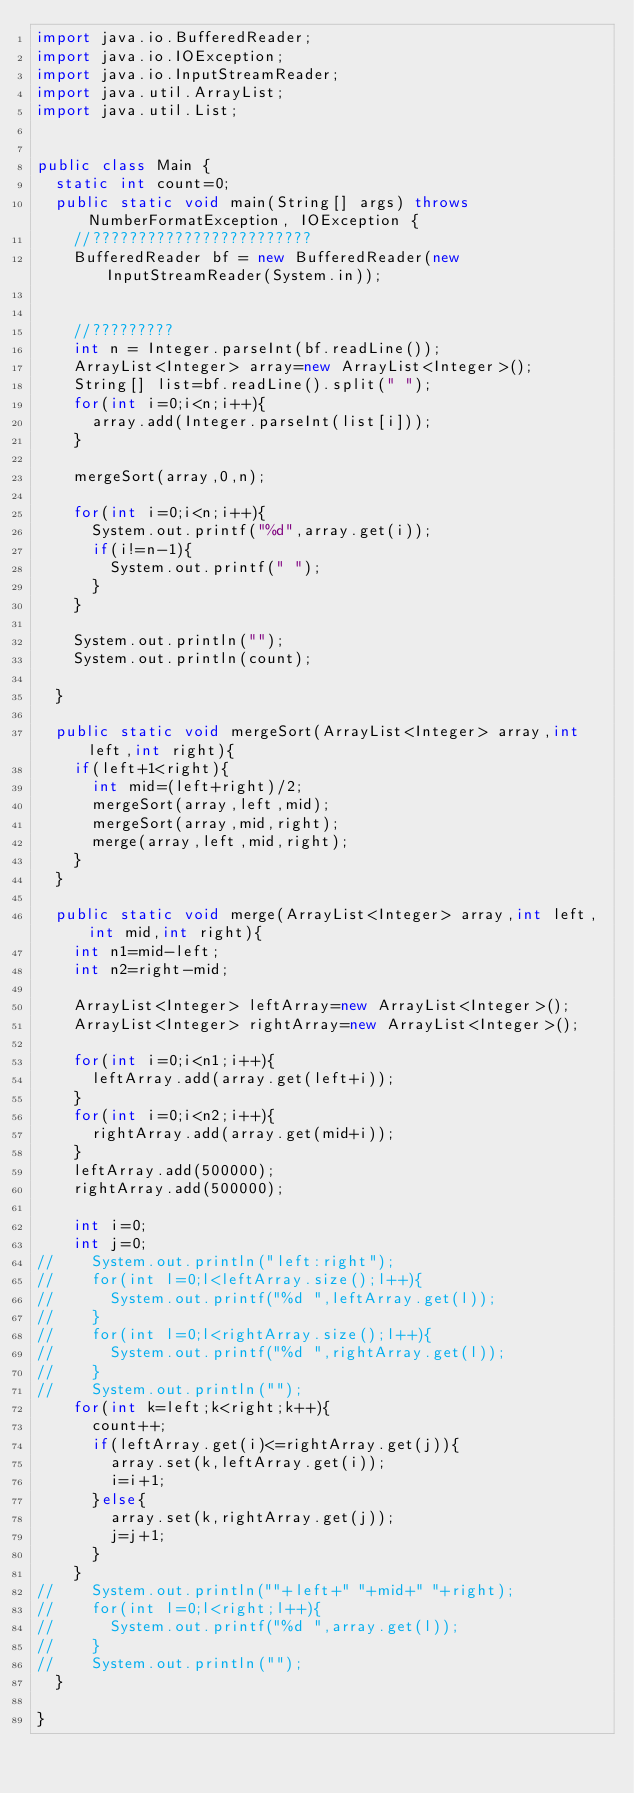Convert code to text. <code><loc_0><loc_0><loc_500><loc_500><_Java_>import java.io.BufferedReader;
import java.io.IOException;
import java.io.InputStreamReader;
import java.util.ArrayList;
import java.util.List;


public class Main {
	static int count=0;
	public static void main(String[] args) throws NumberFormatException, IOException {
		//????????????????????????
		BufferedReader bf = new BufferedReader(new InputStreamReader(System.in));

		
		//?????????
		int n = Integer.parseInt(bf.readLine());
		ArrayList<Integer> array=new ArrayList<Integer>();
		String[] list=bf.readLine().split(" ");
		for(int i=0;i<n;i++){
			array.add(Integer.parseInt(list[i]));
		}
		
		mergeSort(array,0,n);
		
		for(int i=0;i<n;i++){
			System.out.printf("%d",array.get(i));
			if(i!=n-1){
				System.out.printf(" ");
			}
		}

		System.out.println("");
		System.out.println(count);
		
	}
	
	public static void mergeSort(ArrayList<Integer> array,int left,int right){
		if(left+1<right){
			int mid=(left+right)/2;
			mergeSort(array,left,mid);
			mergeSort(array,mid,right);
			merge(array,left,mid,right);
		}
	}
	
	public static void merge(ArrayList<Integer> array,int left,int mid,int right){
		int n1=mid-left;
		int n2=right-mid;
		
		ArrayList<Integer> leftArray=new ArrayList<Integer>();
		ArrayList<Integer> rightArray=new ArrayList<Integer>();
		
		for(int i=0;i<n1;i++){
			leftArray.add(array.get(left+i));
		}
		for(int i=0;i<n2;i++){
			rightArray.add(array.get(mid+i));
		}
		leftArray.add(500000);
		rightArray.add(500000);
		
		int i=0;
		int j=0;
//		System.out.println("left:right");
//		for(int l=0;l<leftArray.size();l++){
//			System.out.printf("%d ",leftArray.get(l));
//		}
//		for(int l=0;l<rightArray.size();l++){
//			System.out.printf("%d ",rightArray.get(l));
//		}
//		System.out.println("");
		for(int k=left;k<right;k++){
			count++;
			if(leftArray.get(i)<=rightArray.get(j)){
				array.set(k,leftArray.get(i));
				i=i+1;
			}else{
				array.set(k,rightArray.get(j));
				j=j+1;
			}
		}
//		System.out.println(""+left+" "+mid+" "+right);
//		for(int l=0;l<right;l++){
//			System.out.printf("%d ",array.get(l));
//		}
//		System.out.println("");
	}

}</code> 